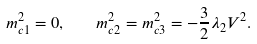<formula> <loc_0><loc_0><loc_500><loc_500>m ^ { 2 } _ { c 1 } = 0 , \quad m ^ { 2 } _ { c 2 } = m ^ { 2 } _ { c 3 } = - \frac { 3 } { 2 } \lambda _ { 2 } V ^ { 2 } .</formula> 